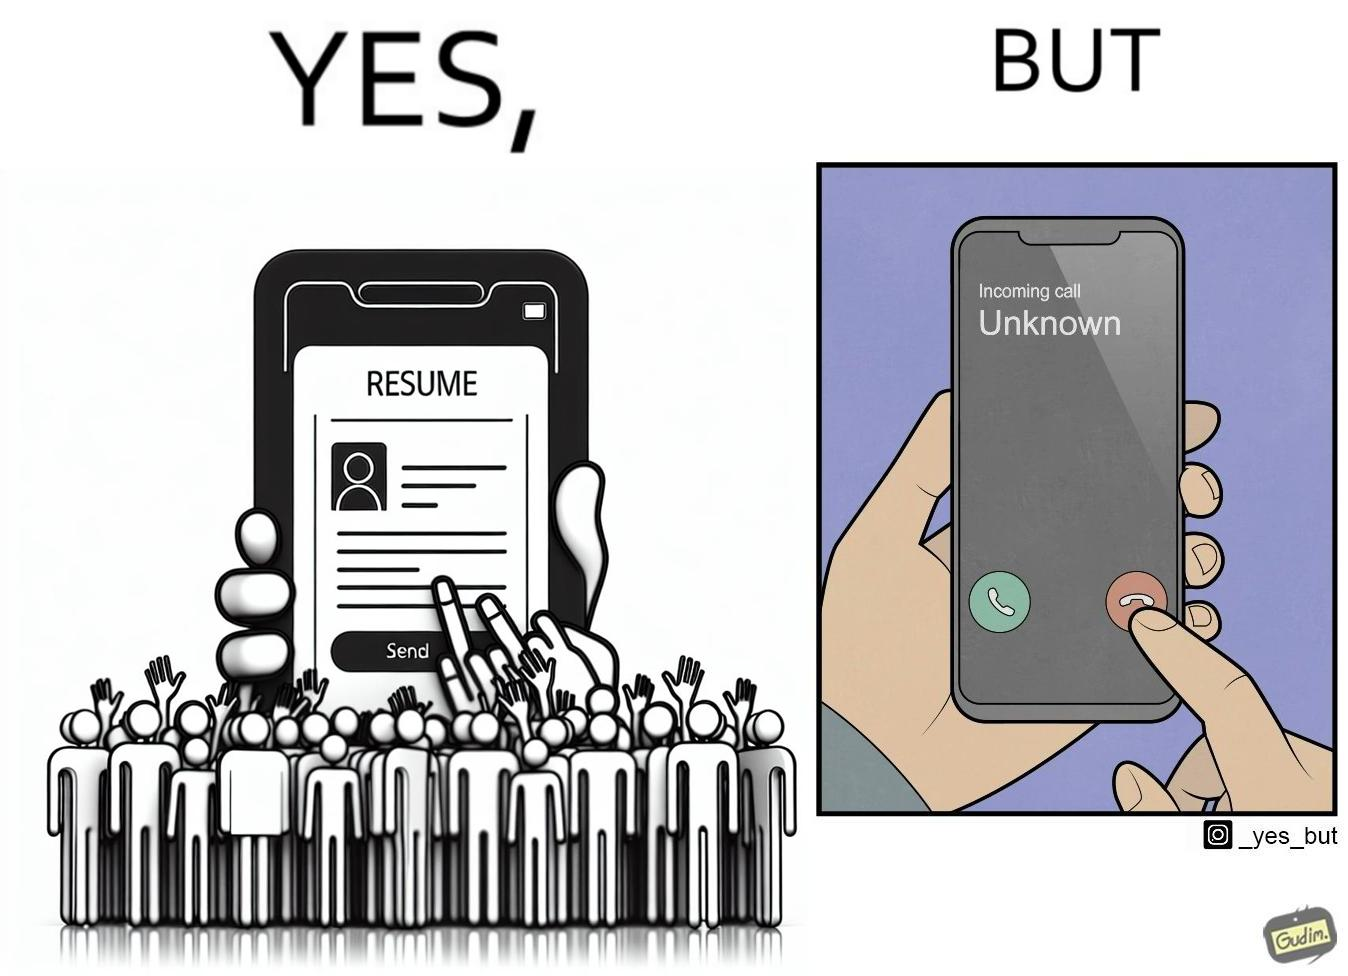What does this image depict? The image is ironic, because on the left image the person is sending their resume to someone and on the right they are rejecting the unknown calls which might be some offer calls  or the person who sent the resume maybe tired of the spam calls after sending the resume which he sent seeking some new oppurtunities 